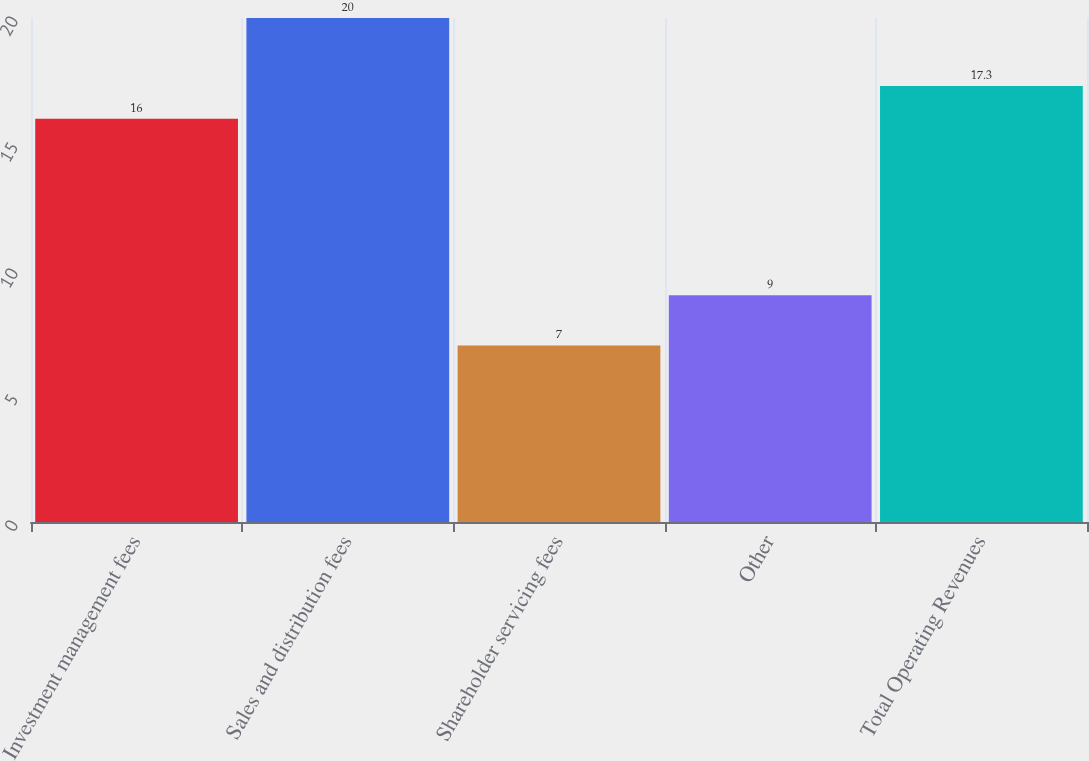Convert chart to OTSL. <chart><loc_0><loc_0><loc_500><loc_500><bar_chart><fcel>Investment management fees<fcel>Sales and distribution fees<fcel>Shareholder servicing fees<fcel>Other<fcel>Total Operating Revenues<nl><fcel>16<fcel>20<fcel>7<fcel>9<fcel>17.3<nl></chart> 